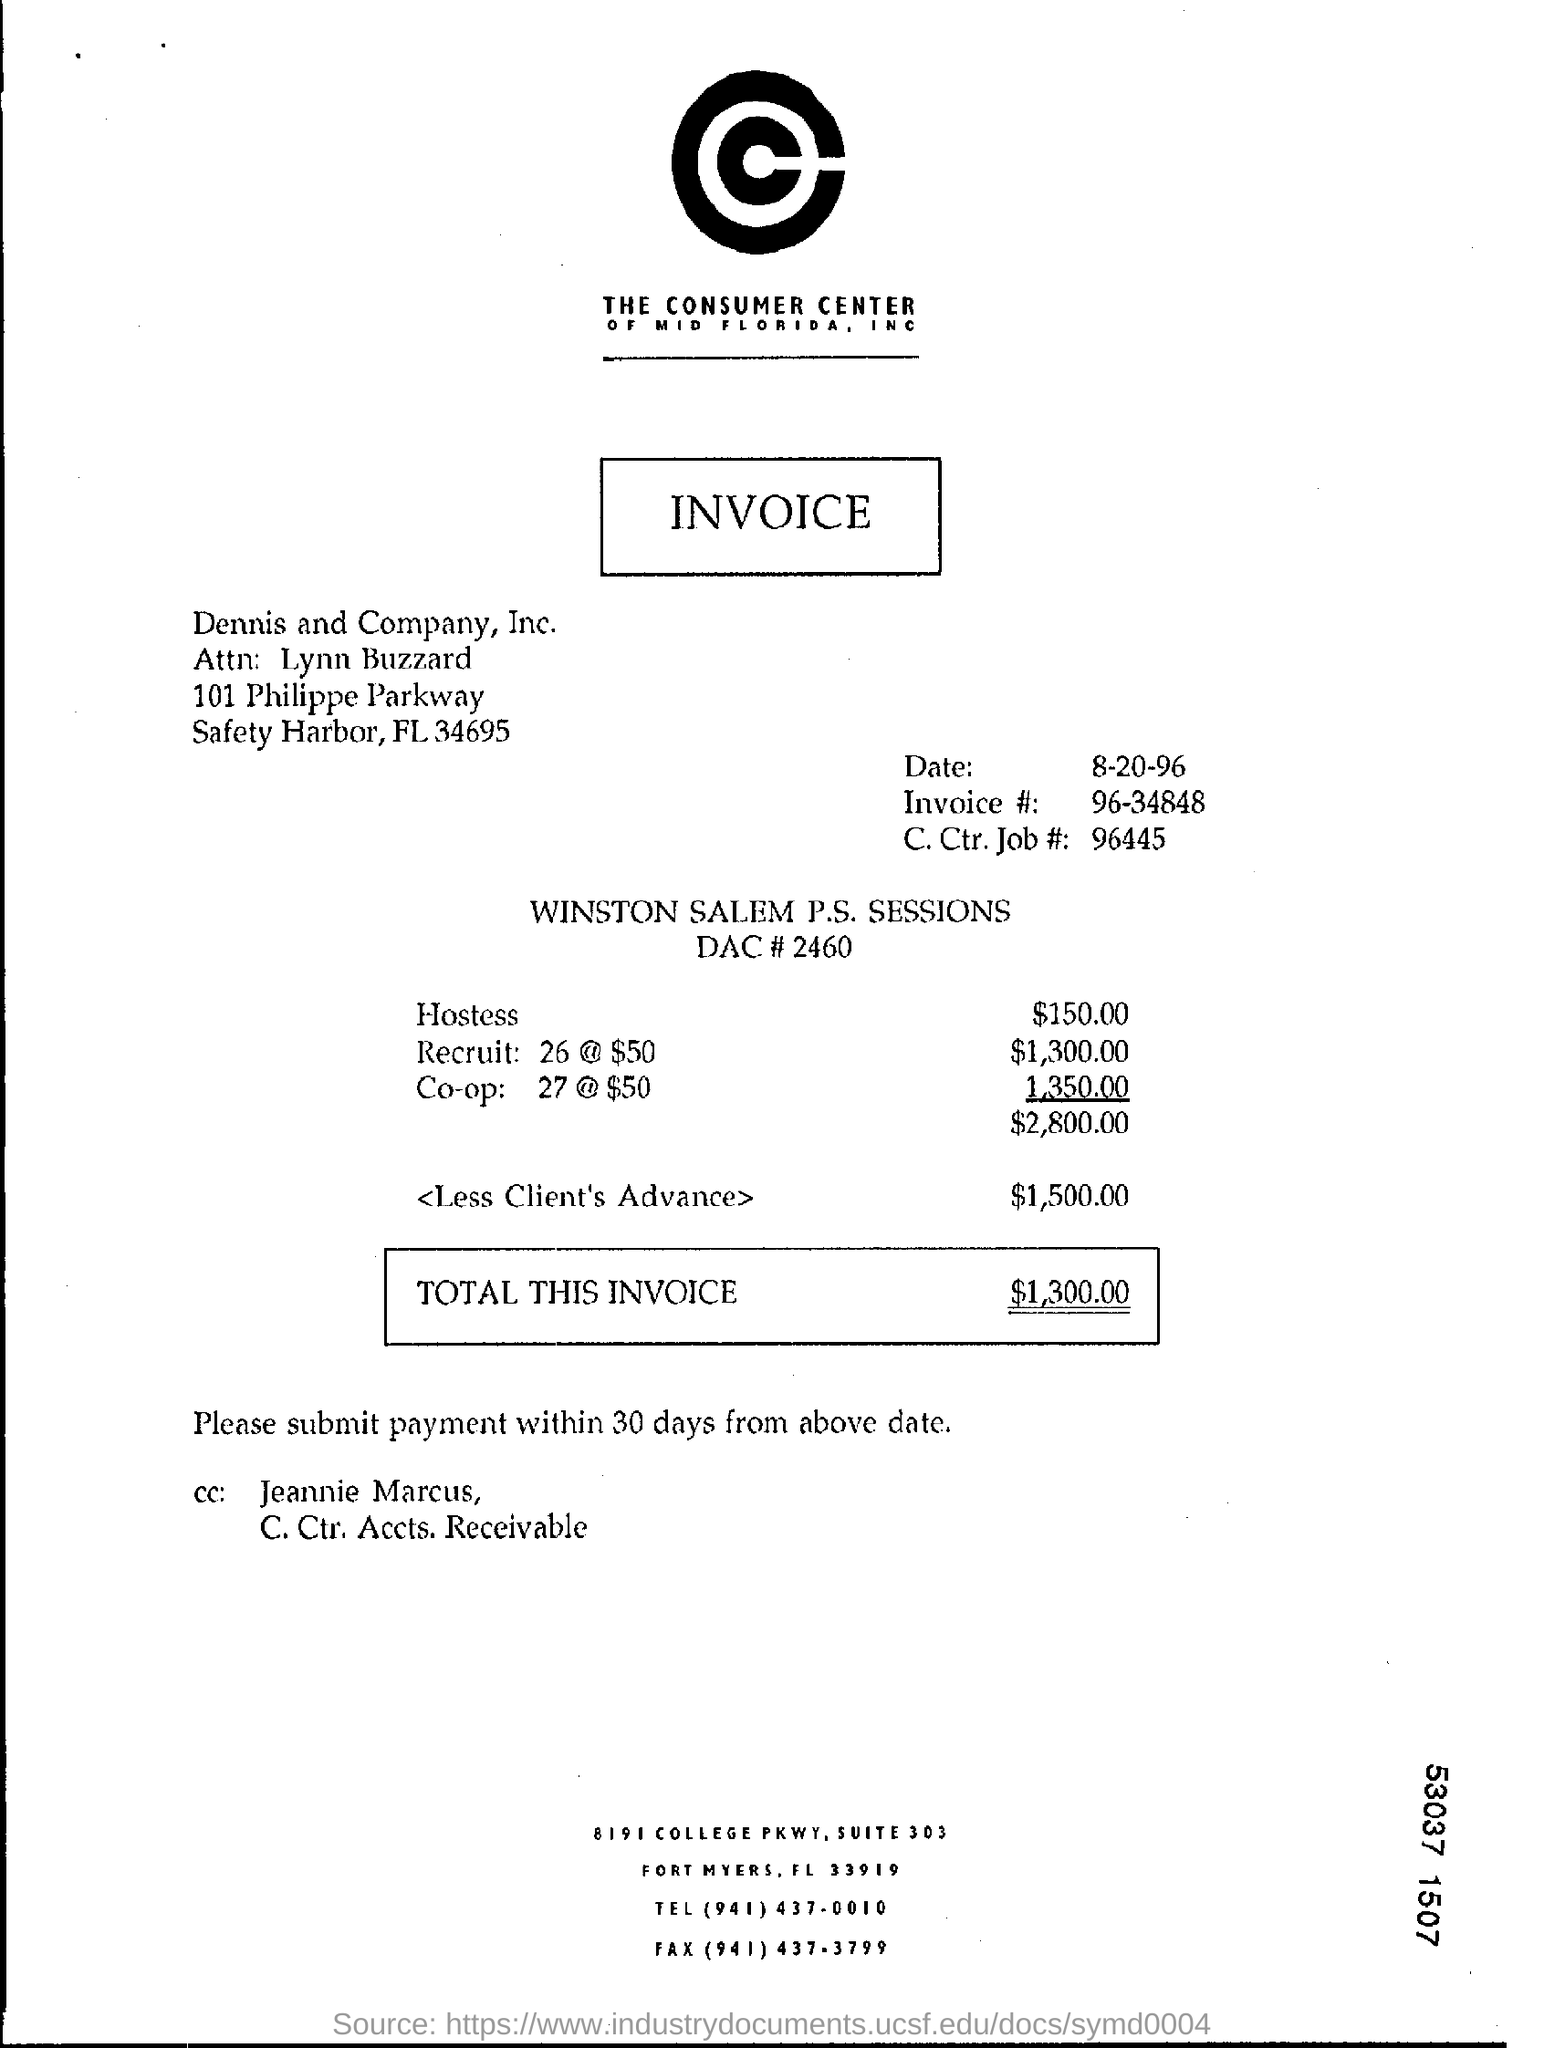Indicate a few pertinent items in this graphic. Dennis and Company, Inc. is currently located in the state of Florida. The invoice is dated August 20, 1996. The individual whose name is listed in the cc field as 'Jeannie Marcus' has been mentioned. The zipcode of Dennis and Company, Inc. is 34695. Please indicate the telephone number at the bottom of the page, which is (941) 437-0010. 